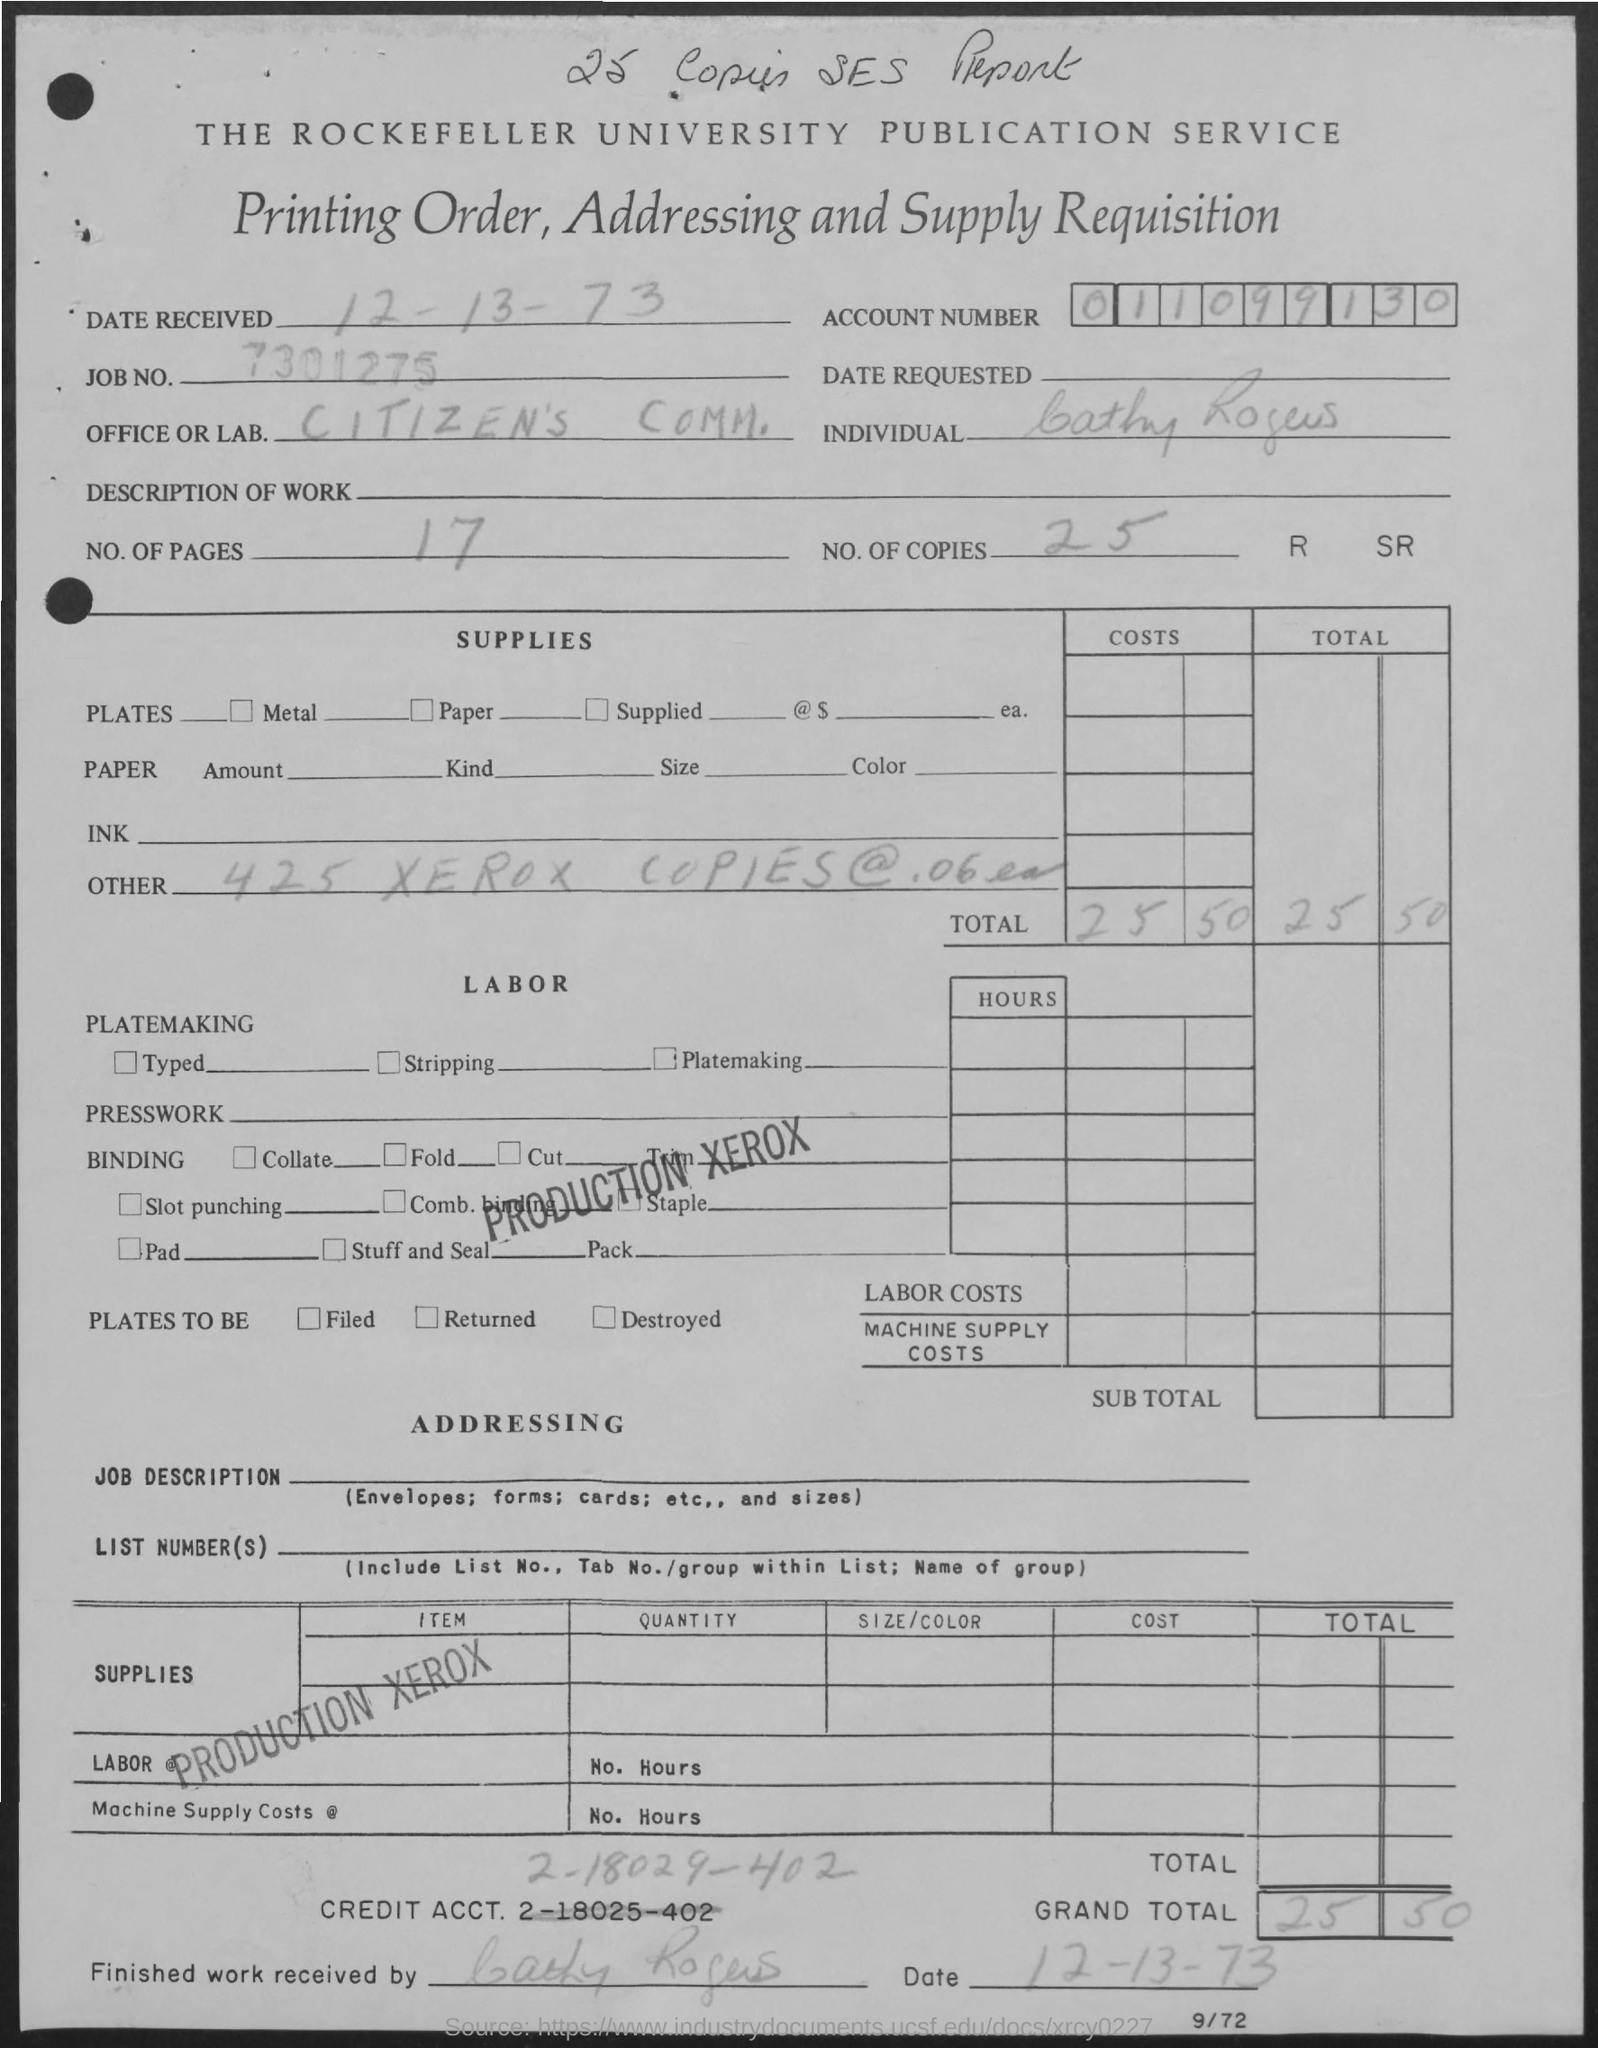Describe the costs outlined in the document. The document lists a total cost of $25.50 for the printing order. This includes the cost for 425 Xerox copies at a rate of 6 cents each, resulting in a subtotal of $25.50, as indicated in the 'COSTS' and 'TOTAL' columns.  What services were requested as part of the printing order? The services requested include 425 Xerox copies and the binding work denoted as 'Production Xerox', which seems to involve comb binding with a custom staple. There is no indication of platemarking or presswork services being required. 